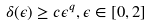<formula> <loc_0><loc_0><loc_500><loc_500>\delta ( \epsilon ) \geq c \epsilon ^ { q } , \epsilon \in [ 0 , 2 ]</formula> 